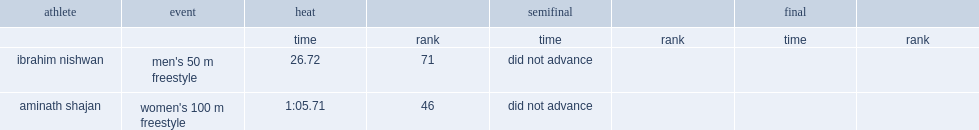What was the result that ibrahim nishwan got in the heat? 26.72. 